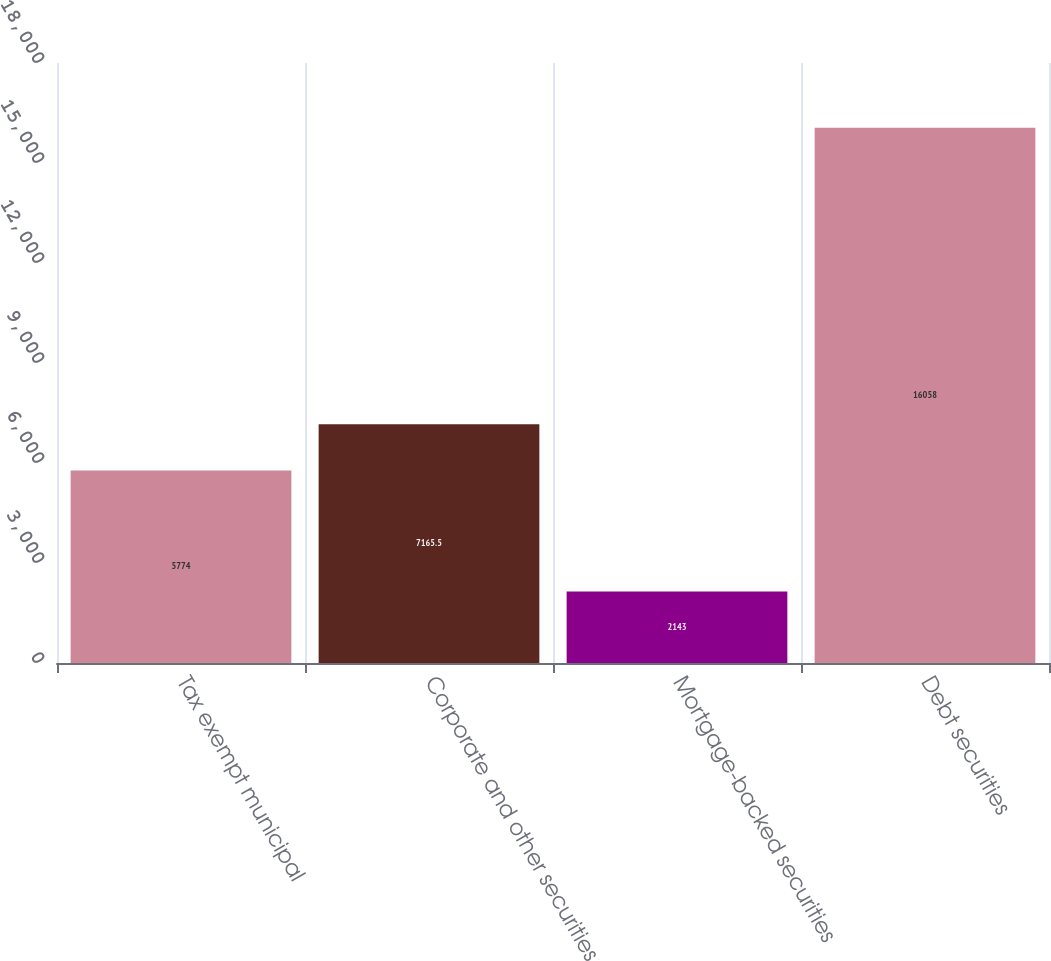Convert chart to OTSL. <chart><loc_0><loc_0><loc_500><loc_500><bar_chart><fcel>Tax exempt municipal<fcel>Corporate and other securities<fcel>Mortgage-backed securities<fcel>Debt securities<nl><fcel>5774<fcel>7165.5<fcel>2143<fcel>16058<nl></chart> 